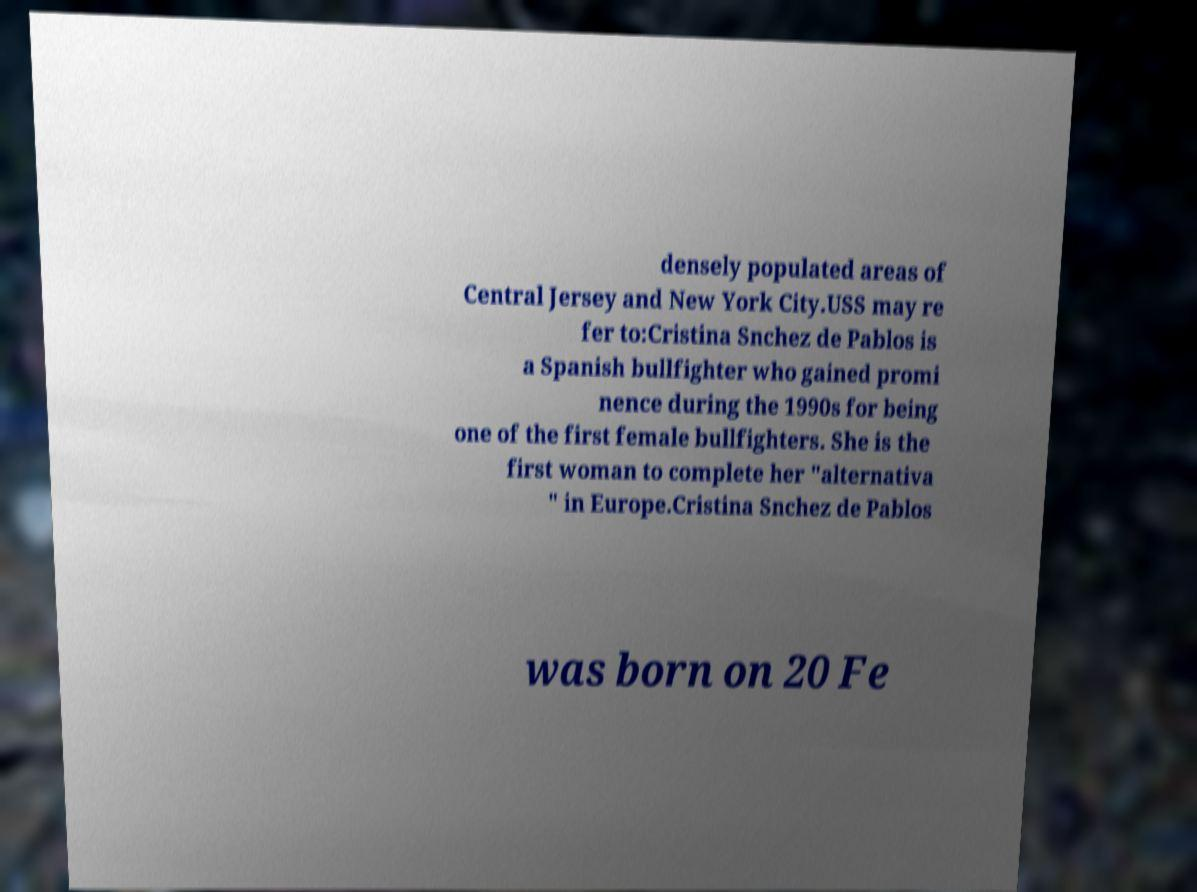For documentation purposes, I need the text within this image transcribed. Could you provide that? densely populated areas of Central Jersey and New York City.USS may re fer to:Cristina Snchez de Pablos is a Spanish bullfighter who gained promi nence during the 1990s for being one of the first female bullfighters. She is the first woman to complete her "alternativa " in Europe.Cristina Snchez de Pablos was born on 20 Fe 